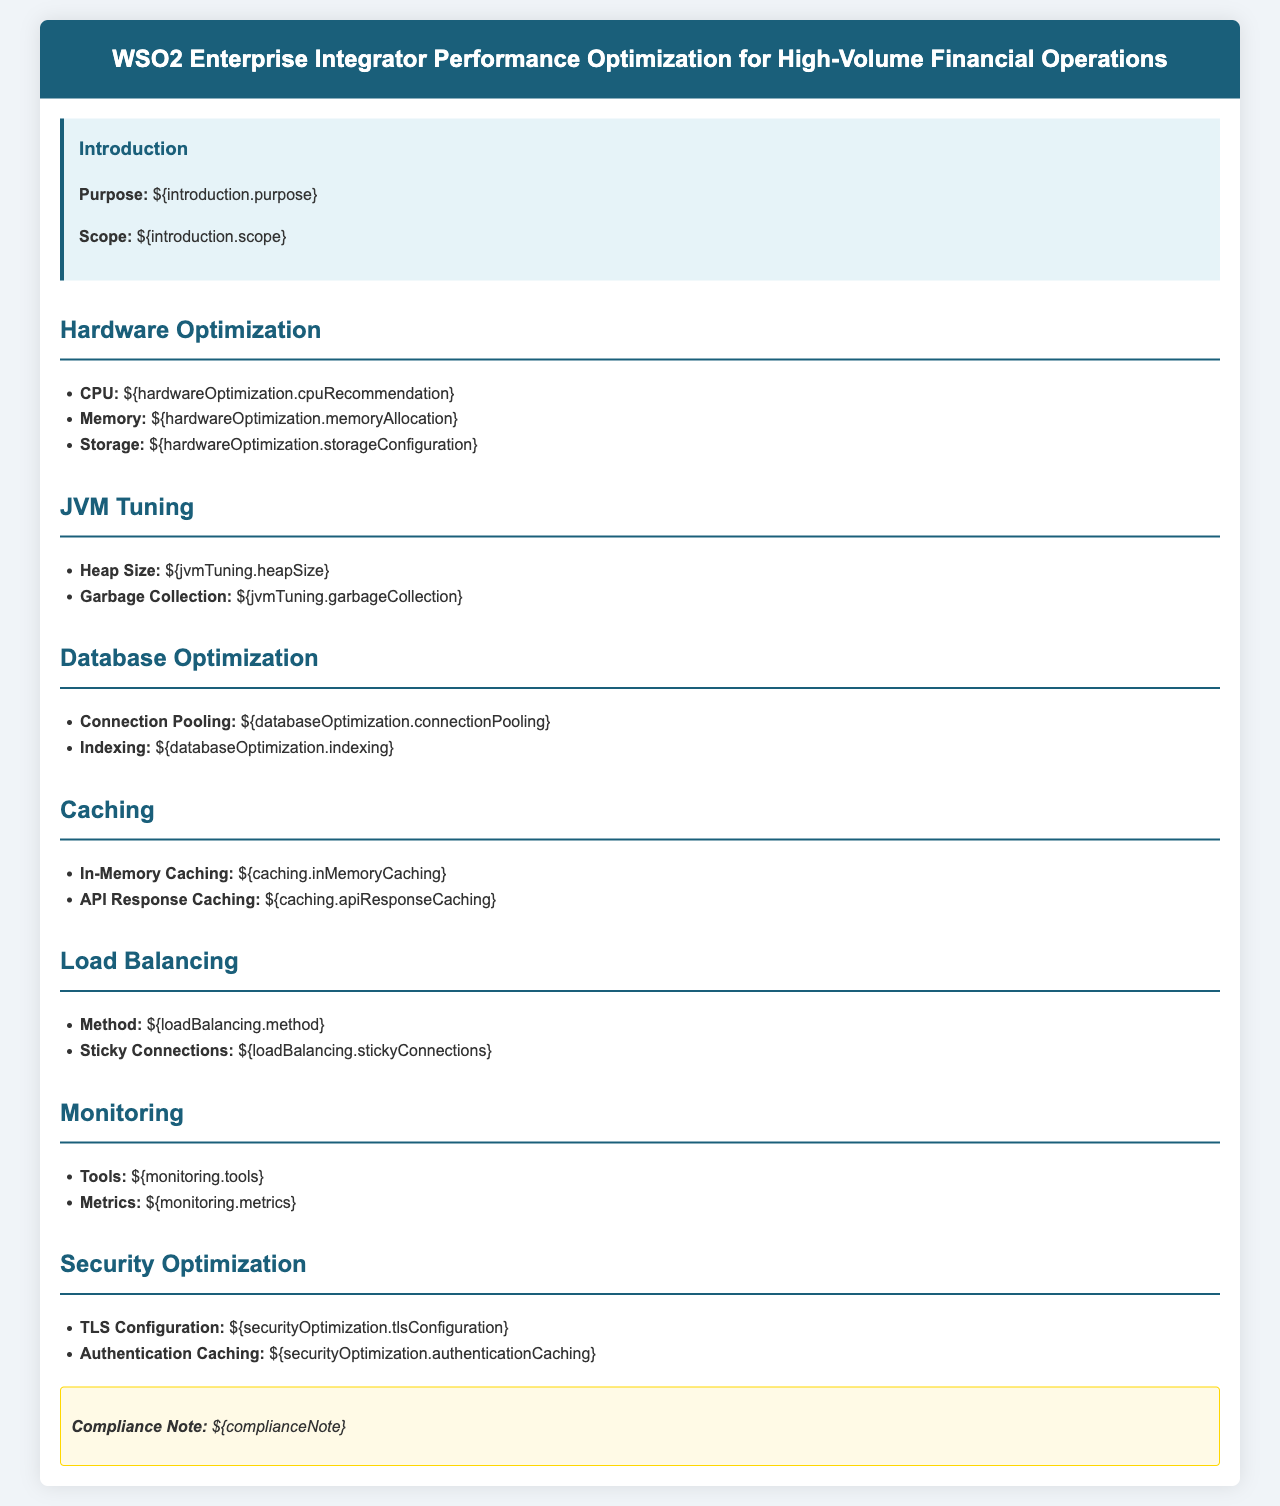What is the purpose of the document? The purpose is stated in the introduction section, which outlines the main goal of the policy regarding performance optimization.
Answer: Optimization for high-volume financial operations What is the recommended CPU configuration? The CPU recommendation is mentioned under hardware optimization, specifying the suggested configuration for optimal performance.
Answer: Specific recommendation not provided What does JVM tuning involve? JVM tuning is addressed in a separate section, detailing adjustments to improve memory management and performance.
Answer: Heap Size and Garbage Collection What is emphasized in Database Optimization? Database optimization focuses on strategies like connection pooling and indexing to enhance database performance.
Answer: Connection Pooling and Indexing What monitoring tools are suggested? The monitoring tools are listed in the monitoring section, indicating what should be used to track performance.
Answer: Specific tools not provided How is load balancing described? The load balancing section describes the method and the concept of sticky connections for better distribution of requests.
Answer: Method and Sticky Connections What caching technique is recommended? Caching techniques like in-memory caching and API response caching are suggested for improved performance.
Answer: In-Memory Caching and API Response Caching What security configuration is included? Security optimization involves configuring TLS and implementing caching for authentication processes to ensure secure communications.
Answer: TLS Configuration and Authentication Caching What compliance aspect is noted in the document? The compliance note is a statement included in the document to highlight regulatory requirements during optimizations.
Answer: Compliance Note shared in the document 